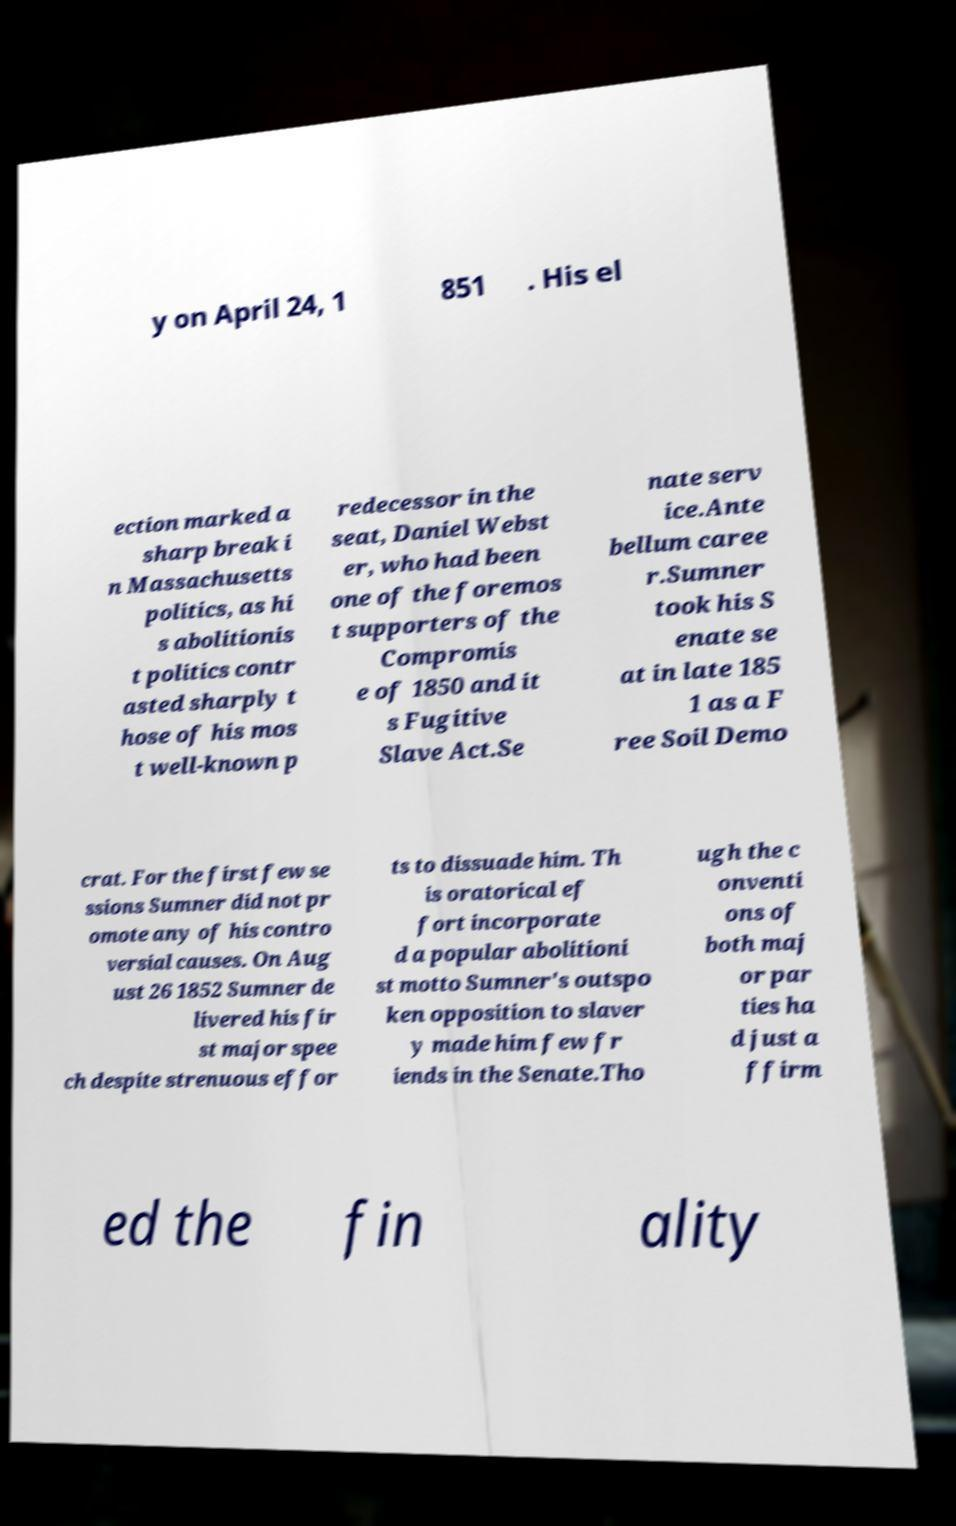Can you accurately transcribe the text from the provided image for me? y on April 24, 1 851 . His el ection marked a sharp break i n Massachusetts politics, as hi s abolitionis t politics contr asted sharply t hose of his mos t well-known p redecessor in the seat, Daniel Webst er, who had been one of the foremos t supporters of the Compromis e of 1850 and it s Fugitive Slave Act.Se nate serv ice.Ante bellum caree r.Sumner took his S enate se at in late 185 1 as a F ree Soil Demo crat. For the first few se ssions Sumner did not pr omote any of his contro versial causes. On Aug ust 26 1852 Sumner de livered his fir st major spee ch despite strenuous effor ts to dissuade him. Th is oratorical ef fort incorporate d a popular abolitioni st motto Sumner's outspo ken opposition to slaver y made him few fr iends in the Senate.Tho ugh the c onventi ons of both maj or par ties ha d just a ffirm ed the fin ality 